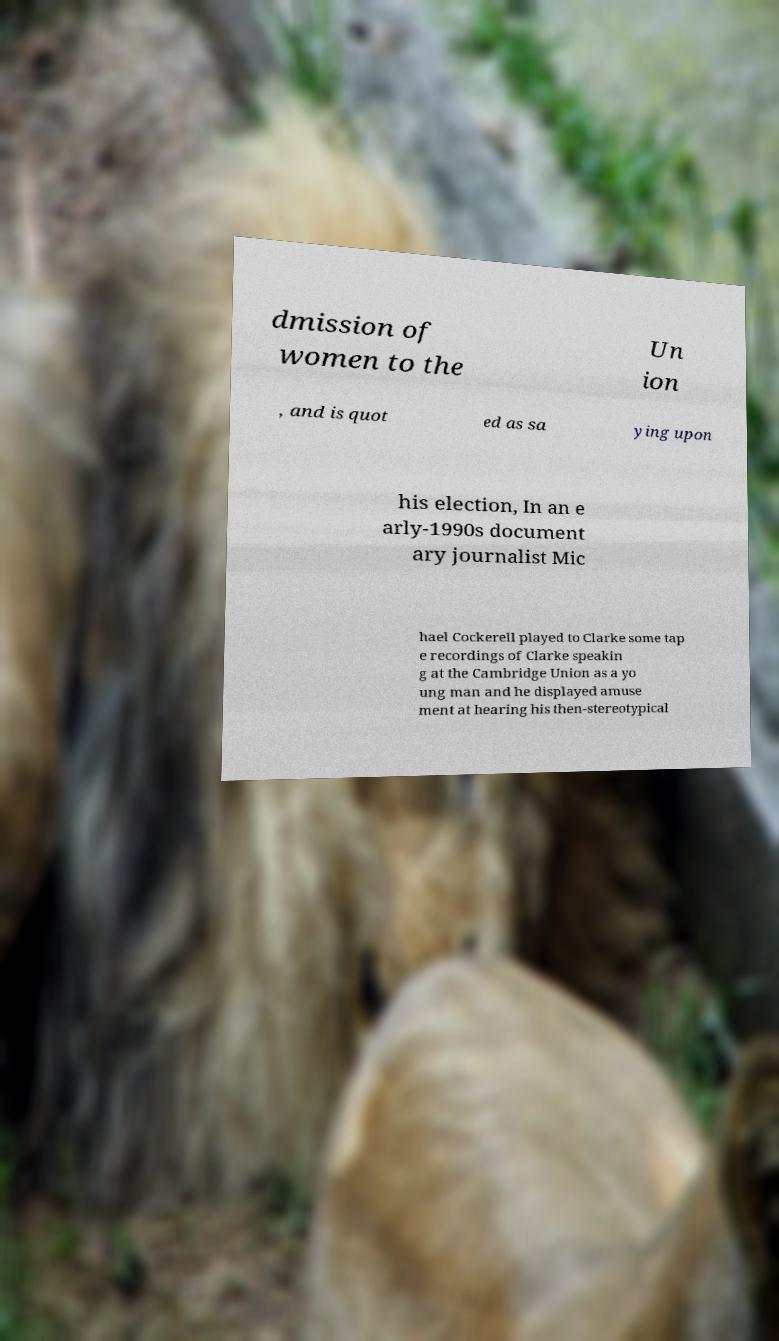Please read and relay the text visible in this image. What does it say? dmission of women to the Un ion , and is quot ed as sa ying upon his election, In an e arly-1990s document ary journalist Mic hael Cockerell played to Clarke some tap e recordings of Clarke speakin g at the Cambridge Union as a yo ung man and he displayed amuse ment at hearing his then-stereotypical 